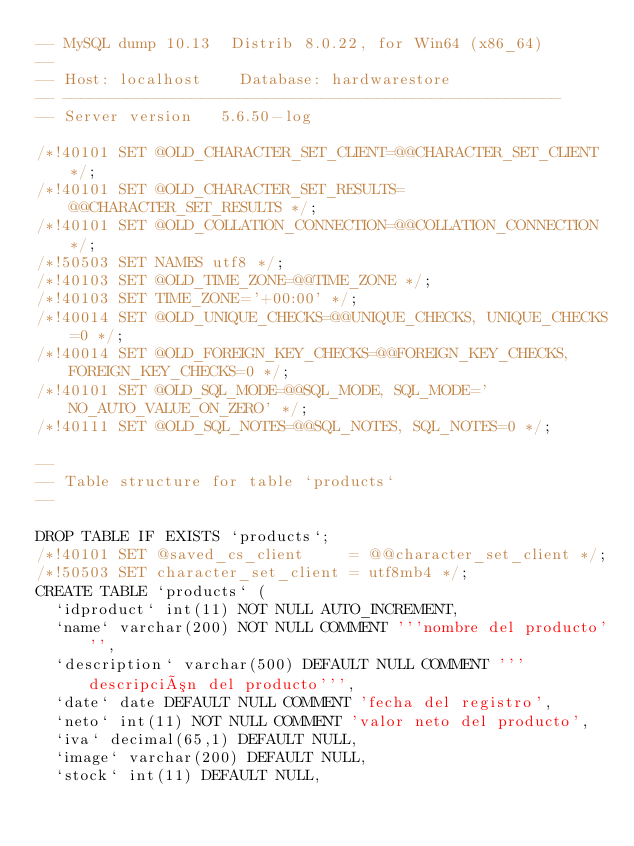Convert code to text. <code><loc_0><loc_0><loc_500><loc_500><_SQL_>-- MySQL dump 10.13  Distrib 8.0.22, for Win64 (x86_64)
--
-- Host: localhost    Database: hardwarestore
-- ------------------------------------------------------
-- Server version	5.6.50-log

/*!40101 SET @OLD_CHARACTER_SET_CLIENT=@@CHARACTER_SET_CLIENT */;
/*!40101 SET @OLD_CHARACTER_SET_RESULTS=@@CHARACTER_SET_RESULTS */;
/*!40101 SET @OLD_COLLATION_CONNECTION=@@COLLATION_CONNECTION */;
/*!50503 SET NAMES utf8 */;
/*!40103 SET @OLD_TIME_ZONE=@@TIME_ZONE */;
/*!40103 SET TIME_ZONE='+00:00' */;
/*!40014 SET @OLD_UNIQUE_CHECKS=@@UNIQUE_CHECKS, UNIQUE_CHECKS=0 */;
/*!40014 SET @OLD_FOREIGN_KEY_CHECKS=@@FOREIGN_KEY_CHECKS, FOREIGN_KEY_CHECKS=0 */;
/*!40101 SET @OLD_SQL_MODE=@@SQL_MODE, SQL_MODE='NO_AUTO_VALUE_ON_ZERO' */;
/*!40111 SET @OLD_SQL_NOTES=@@SQL_NOTES, SQL_NOTES=0 */;

--
-- Table structure for table `products`
--

DROP TABLE IF EXISTS `products`;
/*!40101 SET @saved_cs_client     = @@character_set_client */;
/*!50503 SET character_set_client = utf8mb4 */;
CREATE TABLE `products` (
  `idproduct` int(11) NOT NULL AUTO_INCREMENT,
  `name` varchar(200) NOT NULL COMMENT '''nombre del producto''',
  `description` varchar(500) DEFAULT NULL COMMENT '''descripción del producto''',
  `date` date DEFAULT NULL COMMENT 'fecha del registro',
  `neto` int(11) NOT NULL COMMENT 'valor neto del producto',
  `iva` decimal(65,1) DEFAULT NULL,
  `image` varchar(200) DEFAULT NULL,
  `stock` int(11) DEFAULT NULL,</code> 